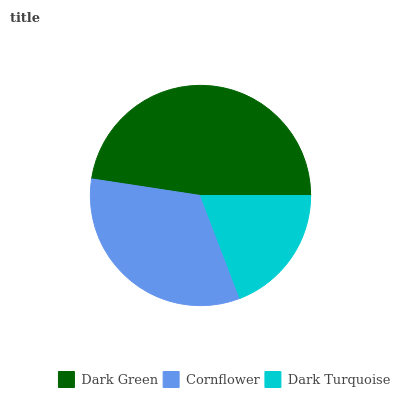Is Dark Turquoise the minimum?
Answer yes or no. Yes. Is Dark Green the maximum?
Answer yes or no. Yes. Is Cornflower the minimum?
Answer yes or no. No. Is Cornflower the maximum?
Answer yes or no. No. Is Dark Green greater than Cornflower?
Answer yes or no. Yes. Is Cornflower less than Dark Green?
Answer yes or no. Yes. Is Cornflower greater than Dark Green?
Answer yes or no. No. Is Dark Green less than Cornflower?
Answer yes or no. No. Is Cornflower the high median?
Answer yes or no. Yes. Is Cornflower the low median?
Answer yes or no. Yes. Is Dark Turquoise the high median?
Answer yes or no. No. Is Dark Green the low median?
Answer yes or no. No. 